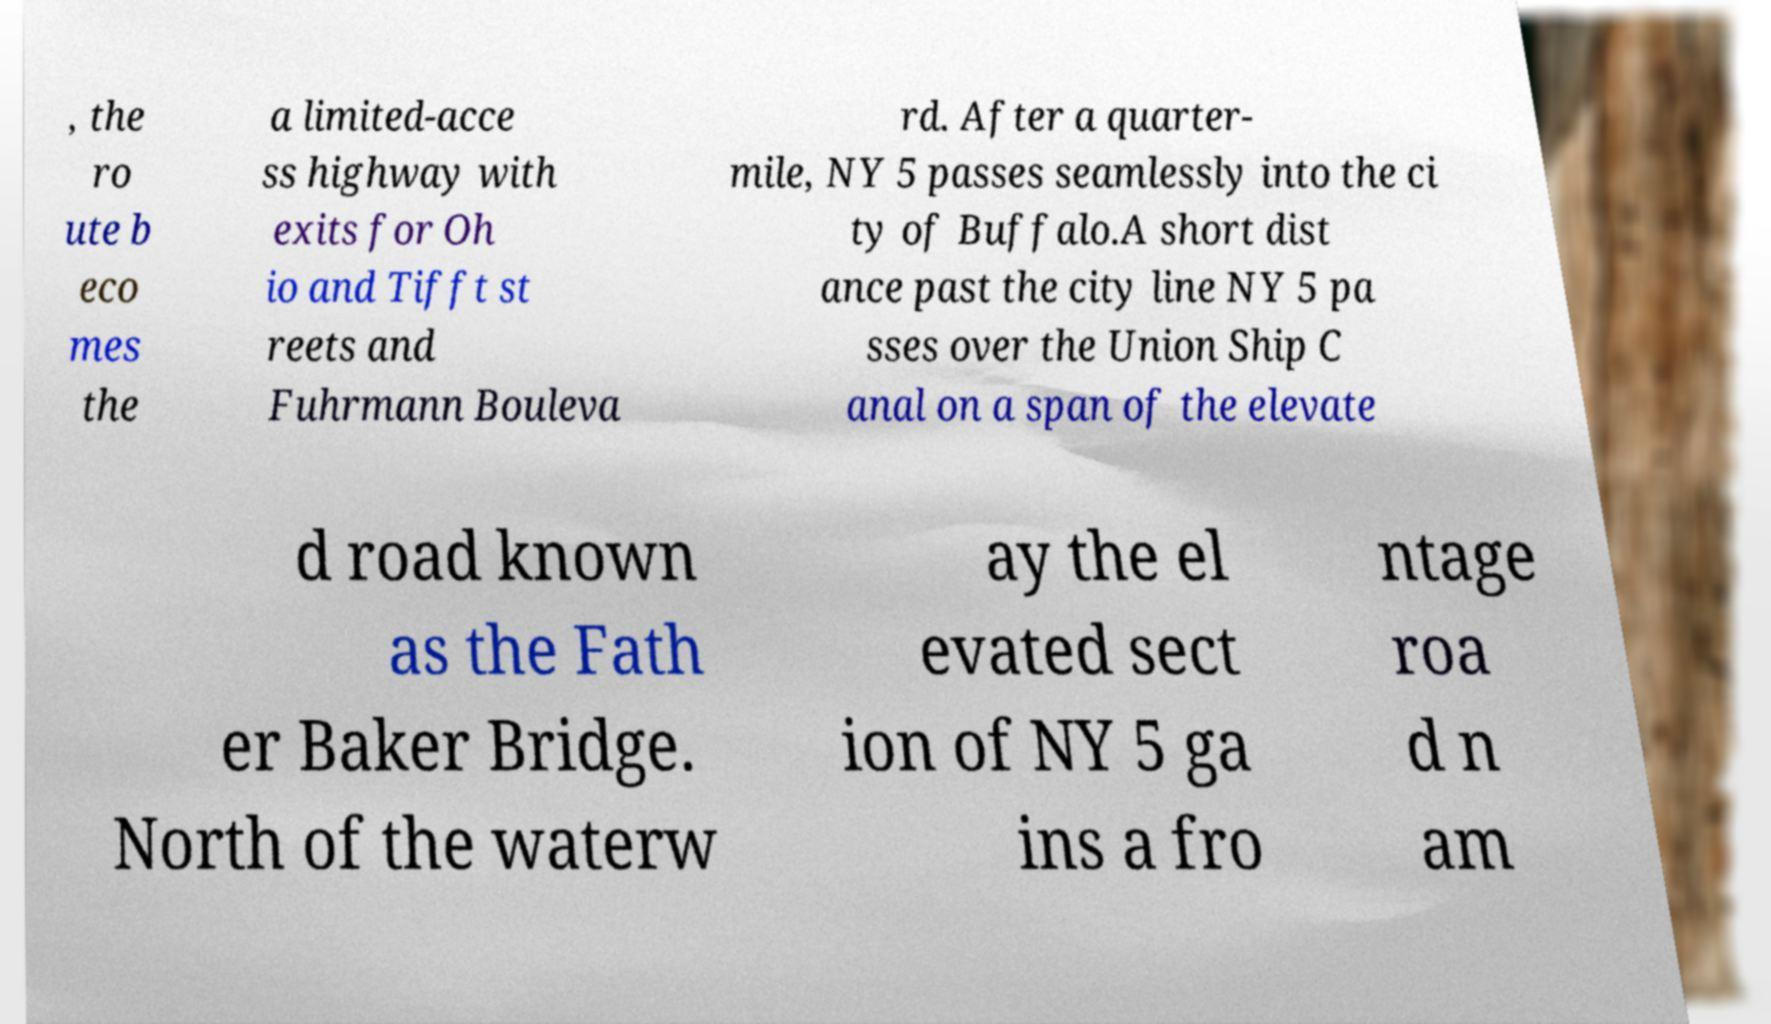There's text embedded in this image that I need extracted. Can you transcribe it verbatim? , the ro ute b eco mes the a limited-acce ss highway with exits for Oh io and Tifft st reets and Fuhrmann Bouleva rd. After a quarter- mile, NY 5 passes seamlessly into the ci ty of Buffalo.A short dist ance past the city line NY 5 pa sses over the Union Ship C anal on a span of the elevate d road known as the Fath er Baker Bridge. North of the waterw ay the el evated sect ion of NY 5 ga ins a fro ntage roa d n am 